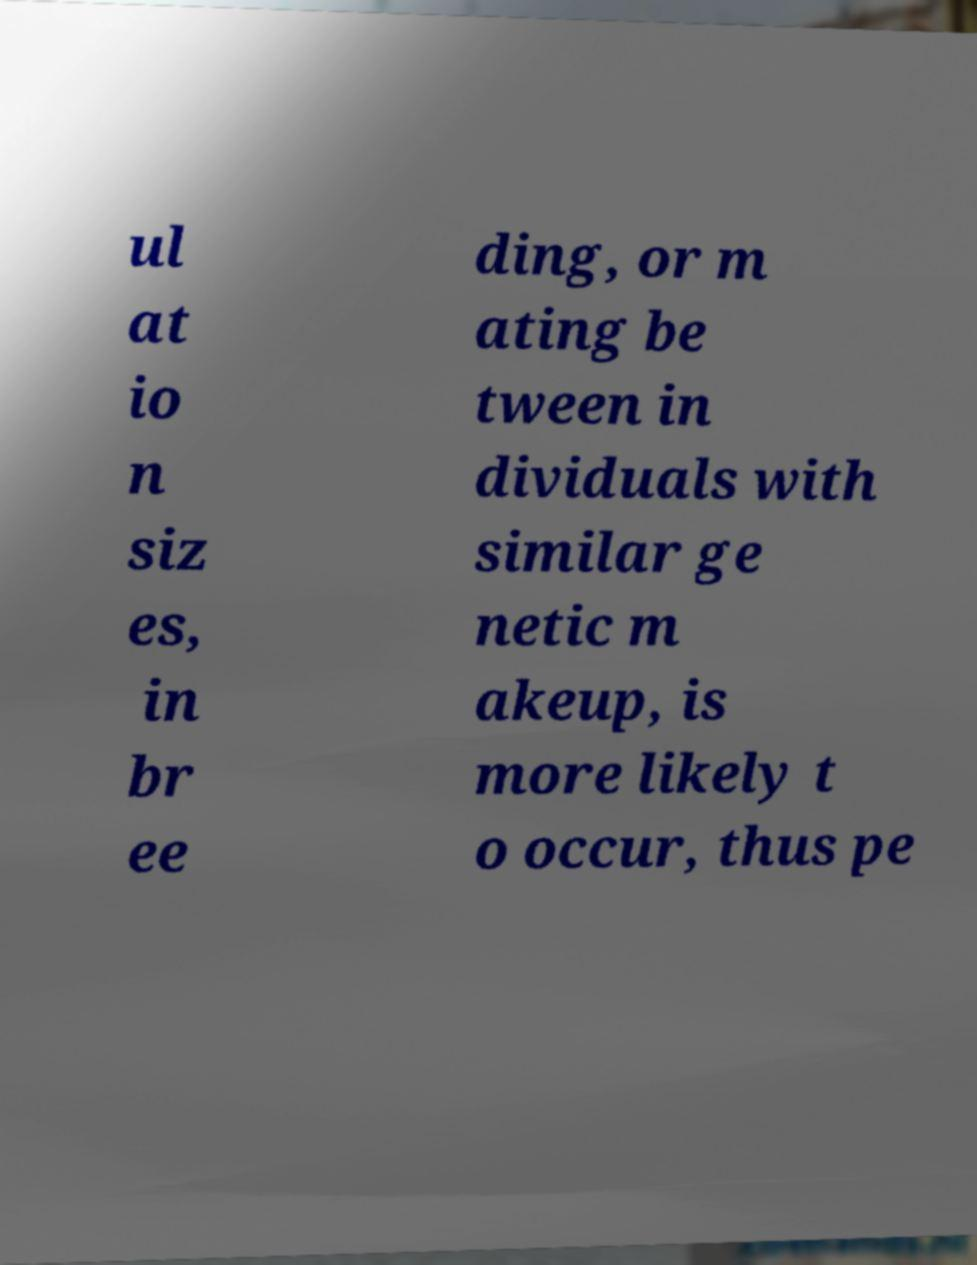Please read and relay the text visible in this image. What does it say? ul at io n siz es, in br ee ding, or m ating be tween in dividuals with similar ge netic m akeup, is more likely t o occur, thus pe 